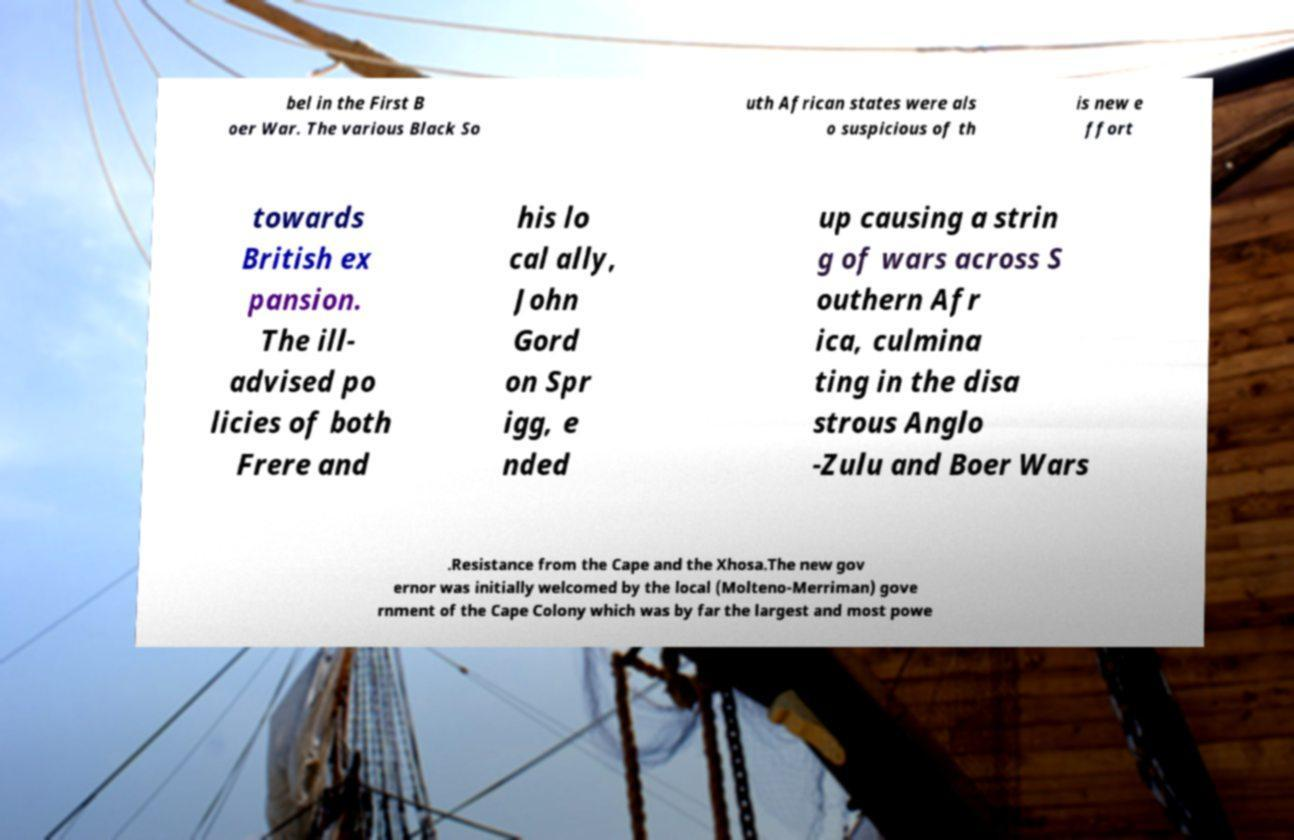There's text embedded in this image that I need extracted. Can you transcribe it verbatim? bel in the First B oer War. The various Black So uth African states were als o suspicious of th is new e ffort towards British ex pansion. The ill- advised po licies of both Frere and his lo cal ally, John Gord on Spr igg, e nded up causing a strin g of wars across S outhern Afr ica, culmina ting in the disa strous Anglo -Zulu and Boer Wars .Resistance from the Cape and the Xhosa.The new gov ernor was initially welcomed by the local (Molteno-Merriman) gove rnment of the Cape Colony which was by far the largest and most powe 